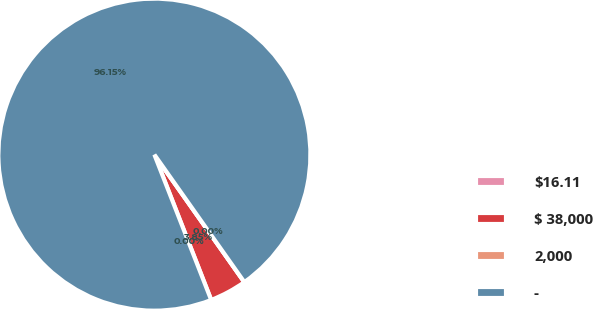Convert chart. <chart><loc_0><loc_0><loc_500><loc_500><pie_chart><fcel>$16.11<fcel>$ 38,000<fcel>2,000<fcel>-<nl><fcel>0.0%<fcel>3.85%<fcel>0.0%<fcel>96.15%<nl></chart> 